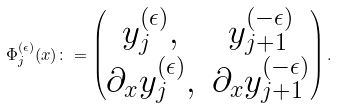<formula> <loc_0><loc_0><loc_500><loc_500>\Phi _ { j } ^ { ( \epsilon ) } ( x ) \colon = \begin{pmatrix} y _ { j } ^ { ( \epsilon ) } , & y _ { j + 1 } ^ { ( - \epsilon ) } \\ \partial _ { x } y _ { j } ^ { ( \epsilon ) } , & \partial _ { x } y _ { j + 1 } ^ { ( - \epsilon ) } \\ \end{pmatrix} .</formula> 